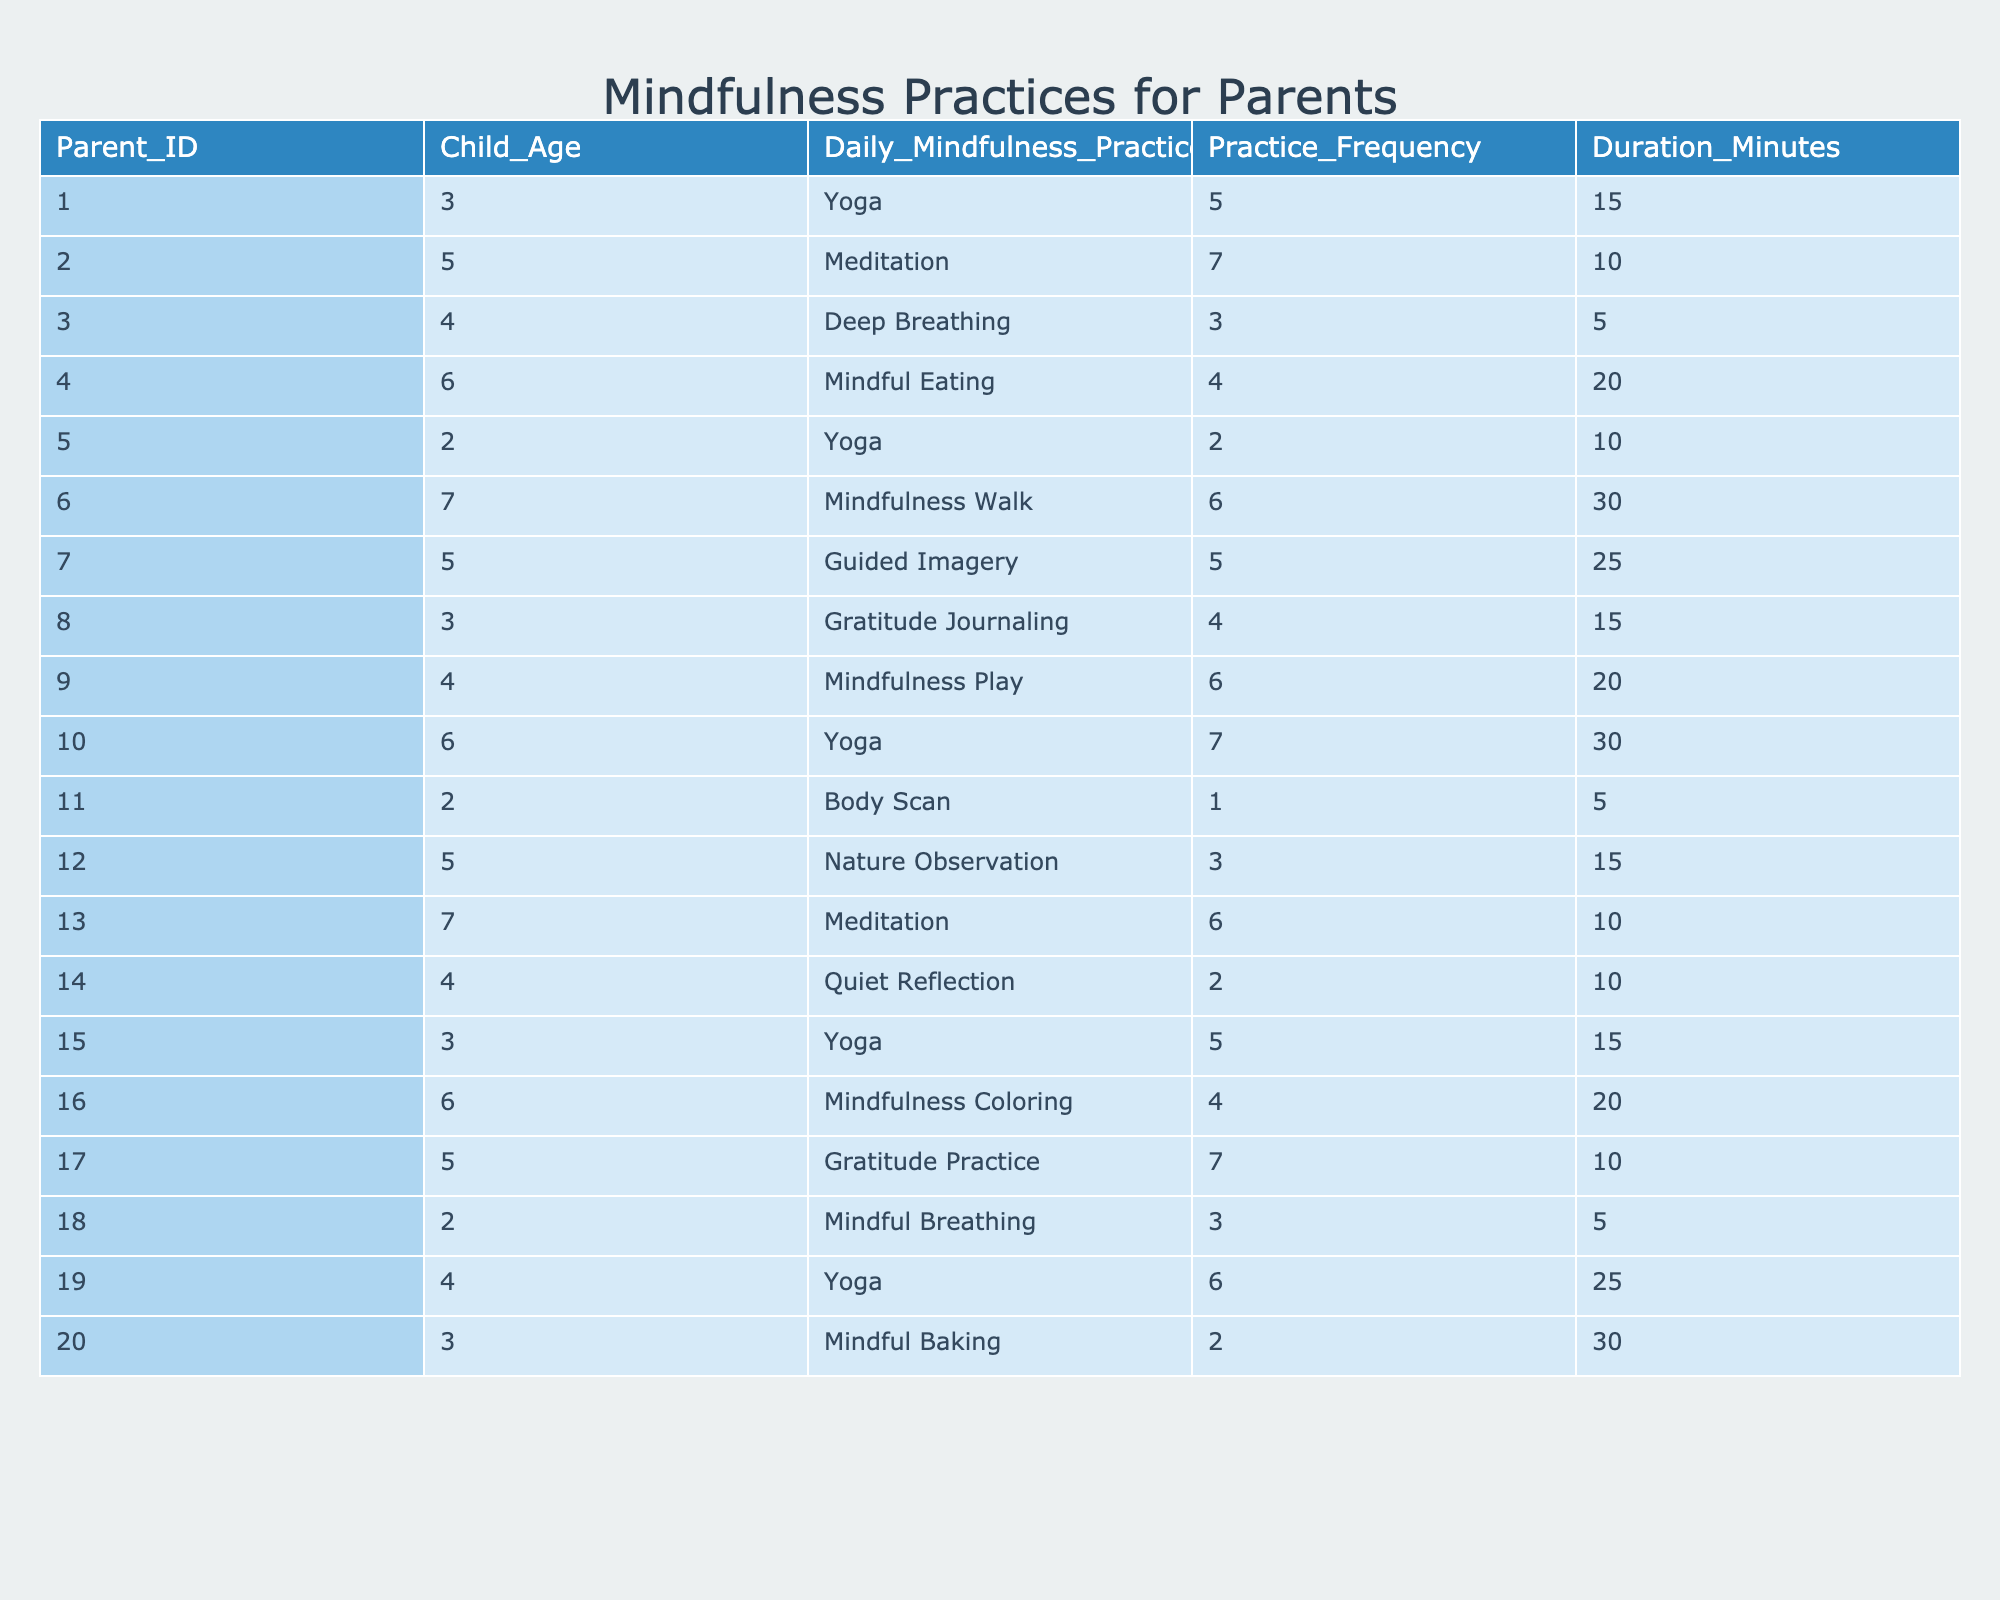What is the most common mindfulness practice among parents? By checking the "Daily_Mindfulness_Practice" column, we can see that "Yoga" appears more frequently than any other practice (it is listed for Parent_IDs 1, 5, 10, 15, and 19).
Answer: Yoga What is the average frequency of mindfulness practices among parents? To find the average frequency, we sum the "Practice_Frequency" values (5 + 7 + 3 + 4 + 2 + 6 + 5 + 4 + 6 + 7 + 1 + 3 + 6 + 2 + 5 + 4 + 7 + 3 + 6 + 2) = 86. There are 20 parents, so the average frequency is 86/20 = 4.3.
Answer: 4.3 Is there a mindfulness practice that lasts longer than 30 minutes? By reviewing the "Duration_Minutes" column, none of the practices exceed 30 minutes; the longest duration listed is 30 minutes.
Answer: No How many parents practice meditation, and what is their average frequency? The "Daily_Mindfulness_Practice" column shows that parents 2 and 13 practice meditation. Their frequencies are 7 and 6 respectively, so the total is 7 + 6 = 13, and the average is 13/2 = 6.5.
Answer: 2 parents, average frequency 6.5 What is the total duration of mindfulness practices for all children aged 4? For children aged 4, the durations are 5, 20, 25 minutes from Parent_IDs 3, 9, and 19. Summing them gives 5 + 20 + 25 = 50 minutes.
Answer: 50 minutes Which mindfulness practice has the lowest frequency and duration, and who practices it? The minimum frequency is 1 (Body Scan by Parent_ID 11), and its duration is also 5 minutes. Comparing others shows no practices are lower, both frequency and duration are the least here.
Answer: Body Scan by Parent_ID 11 Do more parents practice practices that involve movement (like Yoga or Mindfulness Walk)? Looking at the table, 5 parents practice Yoga and 1 parent practices Mindfulness Walk, totaling 6. Comparing this with 14 total parents who do other kinds of practices indicates a larger number for static practices.
Answer: Yes, 6 practice movement-based practices What is the total number of mindfulness practices implemented by parents for children aged 2? For children aged 2, the practices listed are Yoga, Body Scan, and Mindful Breathing, corresponding to Parent_IDs 5, 11, and 18, which number to a total of 3 practices.
Answer: 3 practices What proportion of parents practice guided imagery compared to the total number of parents? Only 1 parent (ID 7) practices Guided Imagery out of 20 parents. The proportion is 1/20 = 0.05.
Answer: 0.05 Is there a relationship between child age and the frequency of mindfulness practices? Carefully comparing the age and their respective frequencies shows a varied but unclear relationship; while older children like those aged 7 have higher frequencies, there are instances of younger children with equal/frequencies. It appears inconsistent.
Answer: No definitive relationship Which practice has the highest duration and frequency, and who implements it? Among the listed practices, “Yoga” has the highest at 30 minutes (Parent_ID 10) and a frequency of 7, making it stand out for both criteria as the most significant.
Answer: Yoga by Parent_ID 10 